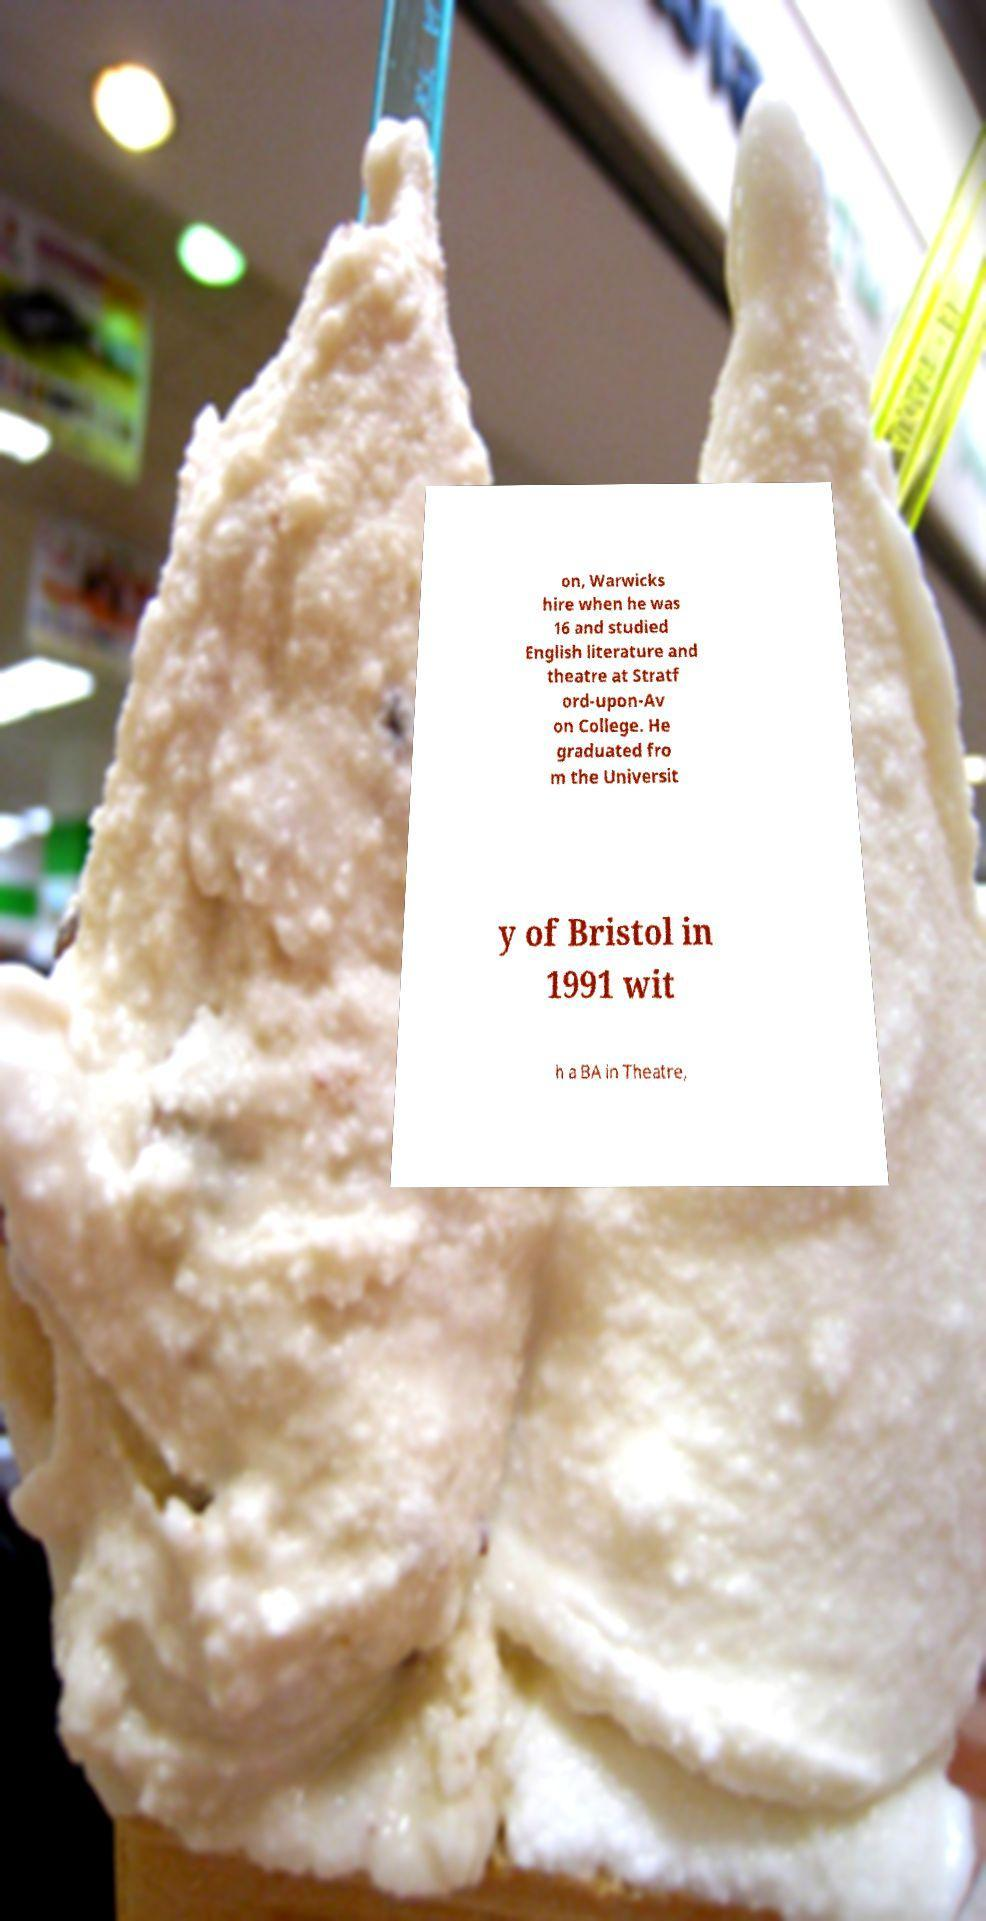Can you read and provide the text displayed in the image?This photo seems to have some interesting text. Can you extract and type it out for me? on, Warwicks hire when he was 16 and studied English literature and theatre at Stratf ord-upon-Av on College. He graduated fro m the Universit y of Bristol in 1991 wit h a BA in Theatre, 